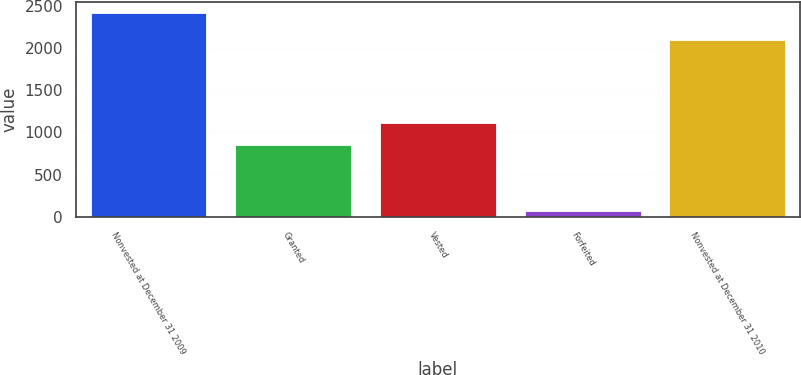Convert chart to OTSL. <chart><loc_0><loc_0><loc_500><loc_500><bar_chart><fcel>Nonvested at December 31 2009<fcel>Granted<fcel>Vested<fcel>Forfeited<fcel>Nonvested at December 31 2010<nl><fcel>2420<fcel>856<fcel>1108<fcel>69<fcel>2099<nl></chart> 